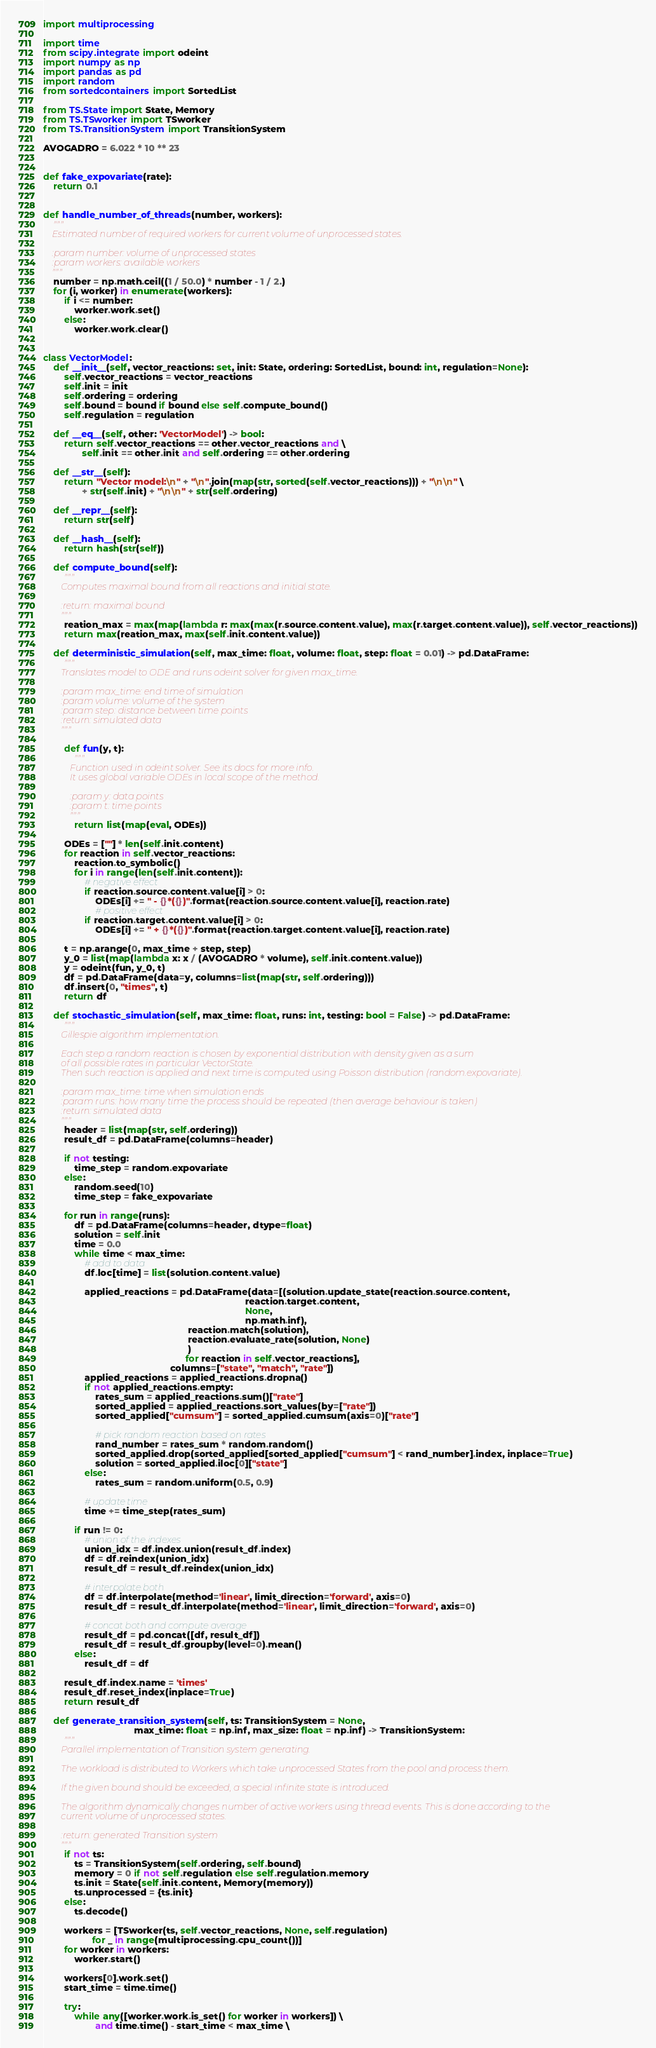Convert code to text. <code><loc_0><loc_0><loc_500><loc_500><_Python_>import multiprocessing

import time
from scipy.integrate import odeint
import numpy as np
import pandas as pd
import random
from sortedcontainers import SortedList

from TS.State import State, Memory
from TS.TSworker import TSworker
from TS.TransitionSystem import TransitionSystem

AVOGADRO = 6.022 * 10 ** 23


def fake_expovariate(rate):
    return 0.1


def handle_number_of_threads(number, workers):
    """
    Estimated number of required workers for current volume of unprocessed states.

    :param number: volume of unprocessed states
    :param workers: available workers
    """
    number = np.math.ceil((1 / 50.0) * number - 1 / 2.)
    for (i, worker) in enumerate(workers):
        if i <= number:
            worker.work.set()
        else:
            worker.work.clear()


class VectorModel:
    def __init__(self, vector_reactions: set, init: State, ordering: SortedList, bound: int, regulation=None):
        self.vector_reactions = vector_reactions
        self.init = init
        self.ordering = ordering
        self.bound = bound if bound else self.compute_bound()
        self.regulation = regulation

    def __eq__(self, other: 'VectorModel') -> bool:
        return self.vector_reactions == other.vector_reactions and \
               self.init == other.init and self.ordering == other.ordering

    def __str__(self):
        return "Vector model:\n" + "\n".join(map(str, sorted(self.vector_reactions))) + "\n\n" \
               + str(self.init) + "\n\n" + str(self.ordering)

    def __repr__(self):
        return str(self)

    def __hash__(self):
        return hash(str(self))

    def compute_bound(self):
        """
        Computes maximal bound from all reactions and initial state.

        :return: maximal bound
        """
        reation_max = max(map(lambda r: max(max(r.source.content.value), max(r.target.content.value)), self.vector_reactions))
        return max(reation_max, max(self.init.content.value))

    def deterministic_simulation(self, max_time: float, volume: float, step: float = 0.01) -> pd.DataFrame:
        """
        Translates model to ODE and runs odeint solver for given max_time.

        :param max_time: end time of simulation
        :param volume: volume of the system
        :param step: distance between time points
        :return: simulated data
        """

        def fun(y, t):
            """
            Function used in odeint solver. See its docs for more info.
            It uses global variable ODEs in local scope of the method.

            :param y: data points
            :param t: time points
            """
            return list(map(eval, ODEs))

        ODEs = [""] * len(self.init.content)
        for reaction in self.vector_reactions:
            reaction.to_symbolic()
            for i in range(len(self.init.content)):
                # negative effect
                if reaction.source.content.value[i] > 0:
                    ODEs[i] += " - {}*({})".format(reaction.source.content.value[i], reaction.rate)
                    # positive effect
                if reaction.target.content.value[i] > 0:
                    ODEs[i] += " + {}*({})".format(reaction.target.content.value[i], reaction.rate)
        
        t = np.arange(0, max_time + step, step)
        y_0 = list(map(lambda x: x / (AVOGADRO * volume), self.init.content.value))
        y = odeint(fun, y_0, t)
        df = pd.DataFrame(data=y, columns=list(map(str, self.ordering)))
        df.insert(0, "times", t)
        return df

    def stochastic_simulation(self, max_time: float, runs: int, testing: bool = False) -> pd.DataFrame:
        """
        Gillespie algorithm implementation.

        Each step a random reaction is chosen by exponential distribution with density given as a sum
        of all possible rates in particular VectorState.
        Then such reaction is applied and next time is computed using Poisson distribution (random.expovariate).

        :param max_time: time when simulation ends
        :param runs: how many time the process should be repeated (then average behaviour is taken)
        :return: simulated data
        """
        header = list(map(str, self.ordering))
        result_df = pd.DataFrame(columns=header)

        if not testing:
            time_step = random.expovariate
        else:
            random.seed(10)
            time_step = fake_expovariate

        for run in range(runs):
            df = pd.DataFrame(columns=header, dtype=float)
            solution = self.init
            time = 0.0
            while time < max_time:
                # add to data
                df.loc[time] = list(solution.content.value)

                applied_reactions = pd.DataFrame(data=[(solution.update_state(reaction.source.content,
                                                                              reaction.target.content,
                                                                              None,
                                                                              np.math.inf),
                                                        reaction.match(solution),
                                                        reaction.evaluate_rate(solution, None)
                                                        )
                                                       for reaction in self.vector_reactions],
                                                 columns=["state", "match", "rate"])
                applied_reactions = applied_reactions.dropna()
                if not applied_reactions.empty:
                    rates_sum = applied_reactions.sum()["rate"]
                    sorted_applied = applied_reactions.sort_values(by=["rate"])
                    sorted_applied["cumsum"] = sorted_applied.cumsum(axis=0)["rate"]

                    # pick random reaction based on rates
                    rand_number = rates_sum * random.random()
                    sorted_applied.drop(sorted_applied[sorted_applied["cumsum"] < rand_number].index, inplace=True)
                    solution = sorted_applied.iloc[0]["state"]
                else:
                    rates_sum = random.uniform(0.5, 0.9)

                # update time
                time += time_step(rates_sum)

            if run != 0:
                # union of the indexes
                union_idx = df.index.union(result_df.index)
                df = df.reindex(union_idx)
                result_df = result_df.reindex(union_idx)

                # interpolate both
                df = df.interpolate(method='linear', limit_direction='forward', axis=0)
                result_df = result_df.interpolate(method='linear', limit_direction='forward', axis=0)

                # concat both and compute average
                result_df = pd.concat([df, result_df])
                result_df = result_df.groupby(level=0).mean()
            else:
                result_df = df

        result_df.index.name = 'times'
        result_df.reset_index(inplace=True)
        return result_df

    def generate_transition_system(self, ts: TransitionSystem = None,
                                   max_time: float = np.inf, max_size: float = np.inf) -> TransitionSystem:
        """
        Parallel implementation of Transition system generating.

        The workload is distributed to Workers which take unprocessed States from the pool and process them.

        If the given bound should be exceeded, a special infinite state is introduced.

        The algorithm dynamically changes number of active workers using thread events. This is done according to the
        current volume of unprocessed states.

        :return: generated Transition system
        """
        if not ts:
            ts = TransitionSystem(self.ordering, self.bound)
            memory = 0 if not self.regulation else self.regulation.memory
            ts.init = State(self.init.content, Memory(memory))
            ts.unprocessed = {ts.init}
        else:
            ts.decode()

        workers = [TSworker(ts, self.vector_reactions, None, self.regulation)
                   for _ in range(multiprocessing.cpu_count())]
        for worker in workers:
            worker.start()

        workers[0].work.set()
        start_time = time.time()

        try:
            while any([worker.work.is_set() for worker in workers]) \
                    and time.time() - start_time < max_time \</code> 